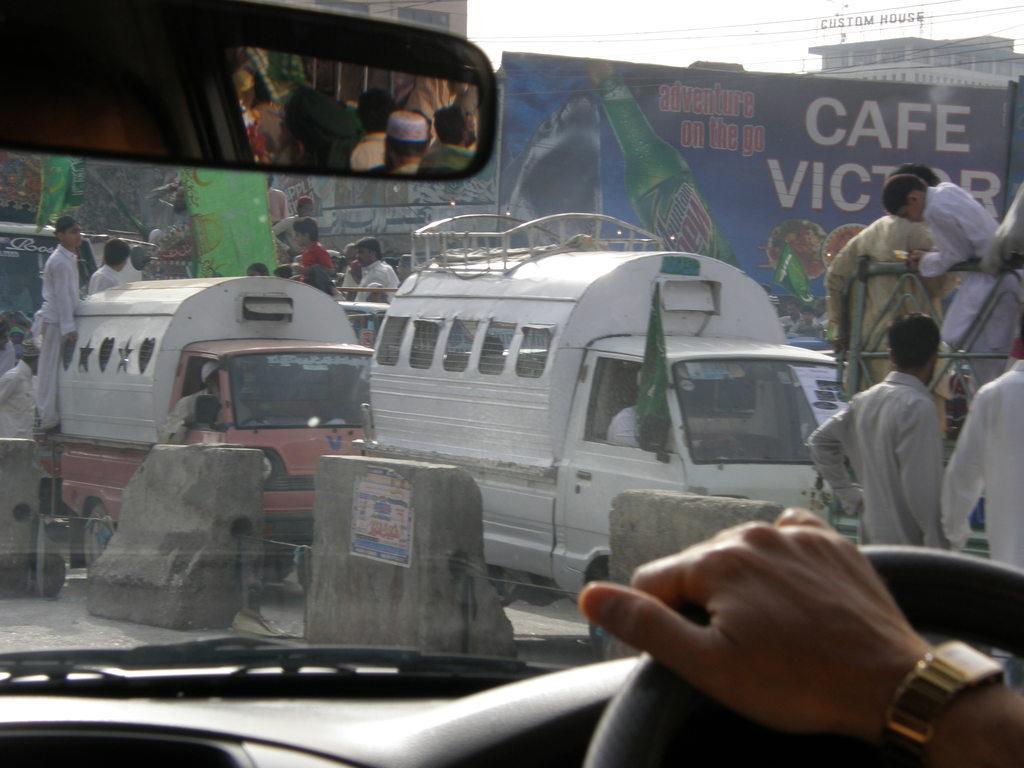Can you describe this image briefly? In this picture we can see inside of a vehicle, here we can see a mirror, windshield wiper and a person holding a steering and in the background we can see vehicles, people, banners, buildings, sky. 